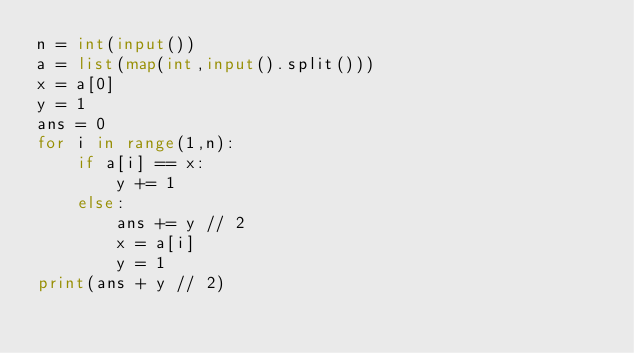Convert code to text. <code><loc_0><loc_0><loc_500><loc_500><_Python_>n = int(input())
a = list(map(int,input().split()))
x = a[0]
y = 1
ans = 0
for i in range(1,n):
    if a[i] == x:
        y += 1
    else:
        ans += y // 2
        x = a[i]
        y = 1
print(ans + y // 2)</code> 